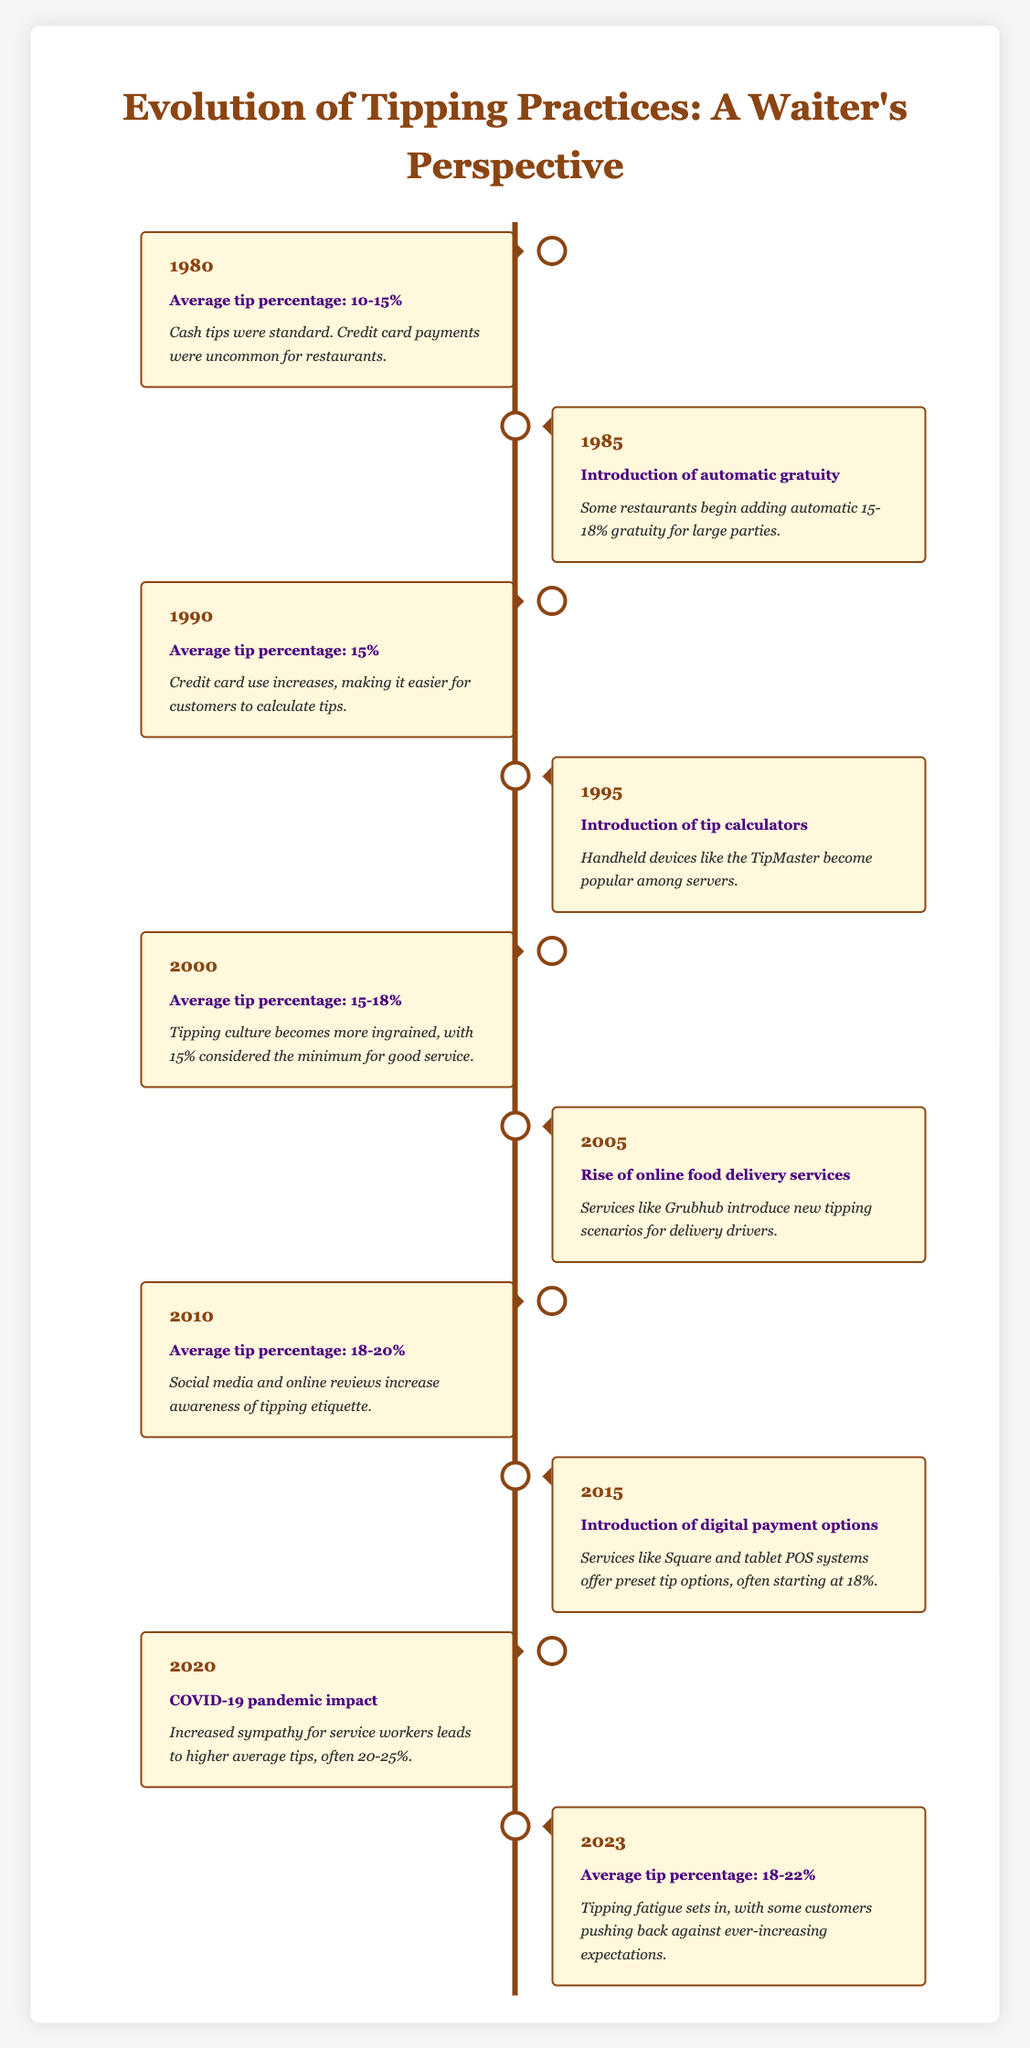What was the average tip percentage in 1990? The table states the average tip percentage was 15% in 1990. This information is directly referenced from the corresponding row for the year 1990.
Answer: 15% What significant change occurred in 1985 regarding tipping practices? In 1985, the introduction of automatic gratuity started, where some restaurants began adding a 15-18% gratuity for large parties. This is captured in the description of the 1985 entry.
Answer: Introduction of automatic gratuity What was the highest average tip percentage recorded in this timeline? The highest average tip percentage mentioned in the timeline is between 20-25% during the COVID-19 pandemic in 2020. This can be determined by comparing all specified averages across the years.
Answer: 20-25% Was there any year when the average tip percentage decreased compared to the previous year? No, there is no year in the table where the average tip percentage decreased compared to the previous year; it has either remained the same or increased. This insight is drawn from observing the average percentages listed for each year.
Answer: No What is the average of the average tip percentages recorded from 1980 to 2023? To find the average of the average tip percentages from each specified year, we calculate the individual percentages: (12.5 + 15 + 15 + 16.5 + 16.5 + 18 + 19 + 18 + 22) / 9 = 17.5%. This gives us the overall average.
Answer: 17.5% How did the introduction of digital payment options in 2015 affect tip practices? The introduction of digital payment options in 2015 offered preset tip choices starting at 18%. This reflects a shift in how tips could be calculated easily due to technological advancements, indicating an increase in expected tip percentages.
Answer: It increased expected tip percentages In which year was the rise of online food delivery services mentioned? The rise of online food delivery services was noted in 2005. This can be directly identified by looking at the entry for the year 2005.
Answer: 2005 What trend can be observed in the average tip percentages from 1980 to 2023? The trend shows a gradual increase in average tip percentages from a range of 10-15% in 1980 to between 18-22% in 2023, indicating an upward movement in tipping culture throughout the years. This observation is made by examining the numerical ranges specified in each year’s data.
Answer: Increasing trend What effect did the COVID-19 pandemic have on tipping practices in 2020? The COVID-19 pandemic led to increased sympathy for service workers, which resulted in higher average tips often recorded between 20-25%. This is outlined in the description of the 2020 entry, indicating a more favorable tipping environment during that time.
Answer: Higher average tips (20-25%) 